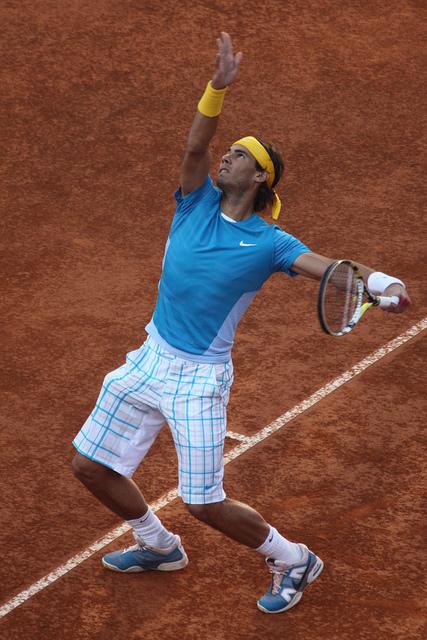Is the player sponsored by Nike?
Keep it brief. Yes. What color are his shoes?
Answer briefly. Blue. What color is the person's headband?
Keep it brief. Yellow. Which hand holds the racket?
Write a very short answer. Left. 